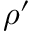<formula> <loc_0><loc_0><loc_500><loc_500>\rho ^ { \prime }</formula> 